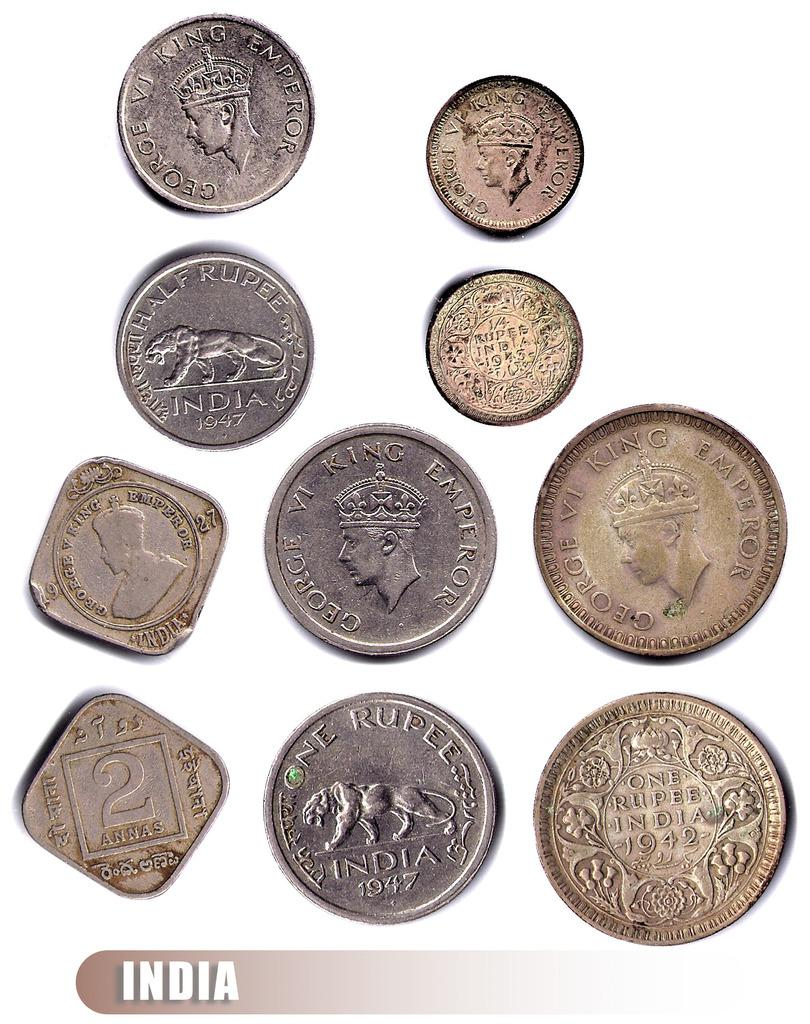<image>
Summarize the visual content of the image. A pile of coins that are labeled India. 